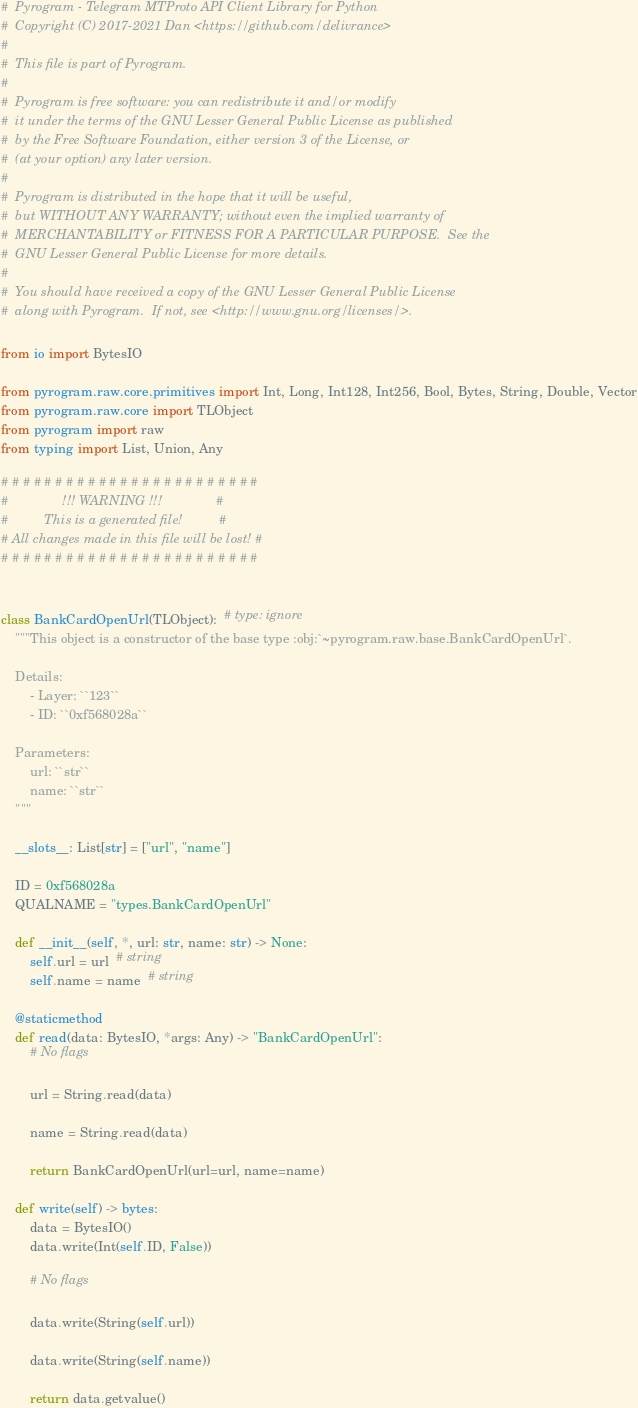<code> <loc_0><loc_0><loc_500><loc_500><_Python_>#  Pyrogram - Telegram MTProto API Client Library for Python
#  Copyright (C) 2017-2021 Dan <https://github.com/delivrance>
#
#  This file is part of Pyrogram.
#
#  Pyrogram is free software: you can redistribute it and/or modify
#  it under the terms of the GNU Lesser General Public License as published
#  by the Free Software Foundation, either version 3 of the License, or
#  (at your option) any later version.
#
#  Pyrogram is distributed in the hope that it will be useful,
#  but WITHOUT ANY WARRANTY; without even the implied warranty of
#  MERCHANTABILITY or FITNESS FOR A PARTICULAR PURPOSE.  See the
#  GNU Lesser General Public License for more details.
#
#  You should have received a copy of the GNU Lesser General Public License
#  along with Pyrogram.  If not, see <http://www.gnu.org/licenses/>.

from io import BytesIO

from pyrogram.raw.core.primitives import Int, Long, Int128, Int256, Bool, Bytes, String, Double, Vector
from pyrogram.raw.core import TLObject
from pyrogram import raw
from typing import List, Union, Any

# # # # # # # # # # # # # # # # # # # # # # # #
#               !!! WARNING !!!               #
#          This is a generated file!          #
# All changes made in this file will be lost! #
# # # # # # # # # # # # # # # # # # # # # # # #


class BankCardOpenUrl(TLObject):  # type: ignore
    """This object is a constructor of the base type :obj:`~pyrogram.raw.base.BankCardOpenUrl`.

    Details:
        - Layer: ``123``
        - ID: ``0xf568028a``

    Parameters:
        url: ``str``
        name: ``str``
    """

    __slots__: List[str] = ["url", "name"]

    ID = 0xf568028a
    QUALNAME = "types.BankCardOpenUrl"

    def __init__(self, *, url: str, name: str) -> None:
        self.url = url  # string
        self.name = name  # string

    @staticmethod
    def read(data: BytesIO, *args: Any) -> "BankCardOpenUrl":
        # No flags

        url = String.read(data)

        name = String.read(data)

        return BankCardOpenUrl(url=url, name=name)

    def write(self) -> bytes:
        data = BytesIO()
        data.write(Int(self.ID, False))

        # No flags

        data.write(String(self.url))

        data.write(String(self.name))

        return data.getvalue()
</code> 